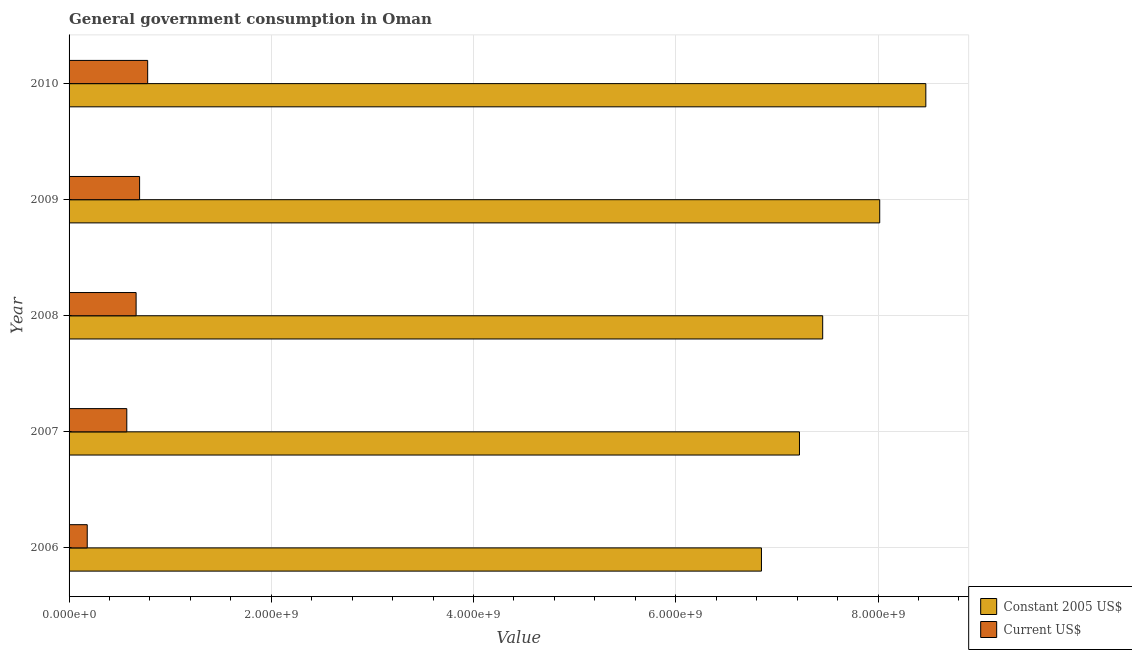How many different coloured bars are there?
Make the answer very short. 2. How many groups of bars are there?
Make the answer very short. 5. Are the number of bars on each tick of the Y-axis equal?
Offer a terse response. Yes. How many bars are there on the 1st tick from the top?
Make the answer very short. 2. How many bars are there on the 3rd tick from the bottom?
Ensure brevity in your answer.  2. What is the label of the 3rd group of bars from the top?
Keep it short and to the point. 2008. In how many cases, is the number of bars for a given year not equal to the number of legend labels?
Make the answer very short. 0. What is the value consumed in current us$ in 2008?
Keep it short and to the point. 6.63e+08. Across all years, what is the maximum value consumed in constant 2005 us$?
Offer a very short reply. 8.47e+09. Across all years, what is the minimum value consumed in constant 2005 us$?
Offer a terse response. 6.85e+09. In which year was the value consumed in constant 2005 us$ maximum?
Offer a very short reply. 2010. What is the total value consumed in current us$ in the graph?
Offer a very short reply. 2.89e+09. What is the difference between the value consumed in current us$ in 2006 and that in 2010?
Your response must be concise. -5.98e+08. What is the difference between the value consumed in constant 2005 us$ in 2008 and the value consumed in current us$ in 2007?
Offer a very short reply. 6.88e+09. What is the average value consumed in constant 2005 us$ per year?
Your answer should be very brief. 7.60e+09. In the year 2007, what is the difference between the value consumed in current us$ and value consumed in constant 2005 us$?
Your response must be concise. -6.65e+09. In how many years, is the value consumed in current us$ greater than 800000000 ?
Provide a succinct answer. 0. What is the ratio of the value consumed in current us$ in 2006 to that in 2007?
Your response must be concise. 0.32. Is the value consumed in current us$ in 2007 less than that in 2008?
Your answer should be compact. Yes. What is the difference between the highest and the second highest value consumed in constant 2005 us$?
Make the answer very short. 4.56e+08. What is the difference between the highest and the lowest value consumed in current us$?
Your response must be concise. 5.98e+08. In how many years, is the value consumed in current us$ greater than the average value consumed in current us$ taken over all years?
Your answer should be very brief. 3. Is the sum of the value consumed in current us$ in 2008 and 2010 greater than the maximum value consumed in constant 2005 us$ across all years?
Give a very brief answer. No. What does the 2nd bar from the top in 2006 represents?
Your answer should be very brief. Constant 2005 US$. What does the 1st bar from the bottom in 2010 represents?
Your answer should be very brief. Constant 2005 US$. How many bars are there?
Offer a very short reply. 10. Are all the bars in the graph horizontal?
Offer a terse response. Yes. Does the graph contain any zero values?
Offer a very short reply. No. Does the graph contain grids?
Make the answer very short. Yes. What is the title of the graph?
Give a very brief answer. General government consumption in Oman. Does "Banks" appear as one of the legend labels in the graph?
Offer a very short reply. No. What is the label or title of the X-axis?
Your response must be concise. Value. What is the label or title of the Y-axis?
Keep it short and to the point. Year. What is the Value in Constant 2005 US$ in 2006?
Provide a succinct answer. 6.85e+09. What is the Value of Current US$ in 2006?
Your answer should be compact. 1.80e+08. What is the Value of Constant 2005 US$ in 2007?
Your answer should be compact. 7.22e+09. What is the Value in Current US$ in 2007?
Offer a terse response. 5.71e+08. What is the Value of Constant 2005 US$ in 2008?
Keep it short and to the point. 7.45e+09. What is the Value in Current US$ in 2008?
Provide a succinct answer. 6.63e+08. What is the Value of Constant 2005 US$ in 2009?
Your answer should be compact. 8.02e+09. What is the Value of Current US$ in 2009?
Your response must be concise. 6.97e+08. What is the Value in Constant 2005 US$ in 2010?
Provide a succinct answer. 8.47e+09. What is the Value in Current US$ in 2010?
Your response must be concise. 7.77e+08. Across all years, what is the maximum Value in Constant 2005 US$?
Your response must be concise. 8.47e+09. Across all years, what is the maximum Value of Current US$?
Your answer should be very brief. 7.77e+08. Across all years, what is the minimum Value in Constant 2005 US$?
Make the answer very short. 6.85e+09. Across all years, what is the minimum Value of Current US$?
Offer a terse response. 1.80e+08. What is the total Value of Constant 2005 US$ in the graph?
Ensure brevity in your answer.  3.80e+1. What is the total Value of Current US$ in the graph?
Provide a short and direct response. 2.89e+09. What is the difference between the Value in Constant 2005 US$ in 2006 and that in 2007?
Your response must be concise. -3.76e+08. What is the difference between the Value of Current US$ in 2006 and that in 2007?
Offer a terse response. -3.91e+08. What is the difference between the Value in Constant 2005 US$ in 2006 and that in 2008?
Your answer should be very brief. -6.06e+08. What is the difference between the Value in Current US$ in 2006 and that in 2008?
Your answer should be compact. -4.83e+08. What is the difference between the Value of Constant 2005 US$ in 2006 and that in 2009?
Offer a very short reply. -1.17e+09. What is the difference between the Value of Current US$ in 2006 and that in 2009?
Make the answer very short. -5.18e+08. What is the difference between the Value of Constant 2005 US$ in 2006 and that in 2010?
Your answer should be compact. -1.63e+09. What is the difference between the Value in Current US$ in 2006 and that in 2010?
Ensure brevity in your answer.  -5.98e+08. What is the difference between the Value in Constant 2005 US$ in 2007 and that in 2008?
Offer a terse response. -2.30e+08. What is the difference between the Value in Current US$ in 2007 and that in 2008?
Your answer should be very brief. -9.21e+07. What is the difference between the Value of Constant 2005 US$ in 2007 and that in 2009?
Offer a very short reply. -7.94e+08. What is the difference between the Value of Current US$ in 2007 and that in 2009?
Give a very brief answer. -1.27e+08. What is the difference between the Value of Constant 2005 US$ in 2007 and that in 2010?
Your response must be concise. -1.25e+09. What is the difference between the Value in Current US$ in 2007 and that in 2010?
Offer a terse response. -2.06e+08. What is the difference between the Value in Constant 2005 US$ in 2008 and that in 2009?
Offer a very short reply. -5.64e+08. What is the difference between the Value in Current US$ in 2008 and that in 2009?
Your response must be concise. -3.45e+07. What is the difference between the Value of Constant 2005 US$ in 2008 and that in 2010?
Your answer should be very brief. -1.02e+09. What is the difference between the Value in Current US$ in 2008 and that in 2010?
Ensure brevity in your answer.  -1.14e+08. What is the difference between the Value of Constant 2005 US$ in 2009 and that in 2010?
Your answer should be very brief. -4.56e+08. What is the difference between the Value in Current US$ in 2009 and that in 2010?
Provide a succinct answer. -7.99e+07. What is the difference between the Value of Constant 2005 US$ in 2006 and the Value of Current US$ in 2007?
Ensure brevity in your answer.  6.28e+09. What is the difference between the Value of Constant 2005 US$ in 2006 and the Value of Current US$ in 2008?
Give a very brief answer. 6.18e+09. What is the difference between the Value of Constant 2005 US$ in 2006 and the Value of Current US$ in 2009?
Offer a very short reply. 6.15e+09. What is the difference between the Value in Constant 2005 US$ in 2006 and the Value in Current US$ in 2010?
Your response must be concise. 6.07e+09. What is the difference between the Value in Constant 2005 US$ in 2007 and the Value in Current US$ in 2008?
Offer a very short reply. 6.56e+09. What is the difference between the Value of Constant 2005 US$ in 2007 and the Value of Current US$ in 2009?
Your answer should be very brief. 6.53e+09. What is the difference between the Value in Constant 2005 US$ in 2007 and the Value in Current US$ in 2010?
Keep it short and to the point. 6.45e+09. What is the difference between the Value of Constant 2005 US$ in 2008 and the Value of Current US$ in 2009?
Your answer should be compact. 6.76e+09. What is the difference between the Value of Constant 2005 US$ in 2008 and the Value of Current US$ in 2010?
Give a very brief answer. 6.68e+09. What is the difference between the Value of Constant 2005 US$ in 2009 and the Value of Current US$ in 2010?
Your answer should be very brief. 7.24e+09. What is the average Value in Constant 2005 US$ per year?
Make the answer very short. 7.60e+09. What is the average Value in Current US$ per year?
Your answer should be compact. 5.78e+08. In the year 2006, what is the difference between the Value in Constant 2005 US$ and Value in Current US$?
Your response must be concise. 6.67e+09. In the year 2007, what is the difference between the Value in Constant 2005 US$ and Value in Current US$?
Give a very brief answer. 6.65e+09. In the year 2008, what is the difference between the Value in Constant 2005 US$ and Value in Current US$?
Provide a succinct answer. 6.79e+09. In the year 2009, what is the difference between the Value of Constant 2005 US$ and Value of Current US$?
Ensure brevity in your answer.  7.32e+09. In the year 2010, what is the difference between the Value of Constant 2005 US$ and Value of Current US$?
Your answer should be compact. 7.70e+09. What is the ratio of the Value in Constant 2005 US$ in 2006 to that in 2007?
Ensure brevity in your answer.  0.95. What is the ratio of the Value in Current US$ in 2006 to that in 2007?
Make the answer very short. 0.31. What is the ratio of the Value of Constant 2005 US$ in 2006 to that in 2008?
Offer a terse response. 0.92. What is the ratio of the Value in Current US$ in 2006 to that in 2008?
Make the answer very short. 0.27. What is the ratio of the Value of Constant 2005 US$ in 2006 to that in 2009?
Your answer should be very brief. 0.85. What is the ratio of the Value in Current US$ in 2006 to that in 2009?
Offer a very short reply. 0.26. What is the ratio of the Value in Constant 2005 US$ in 2006 to that in 2010?
Keep it short and to the point. 0.81. What is the ratio of the Value of Current US$ in 2006 to that in 2010?
Ensure brevity in your answer.  0.23. What is the ratio of the Value of Constant 2005 US$ in 2007 to that in 2008?
Your answer should be compact. 0.97. What is the ratio of the Value in Current US$ in 2007 to that in 2008?
Your answer should be compact. 0.86. What is the ratio of the Value in Constant 2005 US$ in 2007 to that in 2009?
Offer a very short reply. 0.9. What is the ratio of the Value in Current US$ in 2007 to that in 2009?
Ensure brevity in your answer.  0.82. What is the ratio of the Value in Constant 2005 US$ in 2007 to that in 2010?
Give a very brief answer. 0.85. What is the ratio of the Value of Current US$ in 2007 to that in 2010?
Your response must be concise. 0.73. What is the ratio of the Value of Constant 2005 US$ in 2008 to that in 2009?
Keep it short and to the point. 0.93. What is the ratio of the Value of Current US$ in 2008 to that in 2009?
Provide a short and direct response. 0.95. What is the ratio of the Value of Constant 2005 US$ in 2008 to that in 2010?
Keep it short and to the point. 0.88. What is the ratio of the Value in Current US$ in 2008 to that in 2010?
Your answer should be very brief. 0.85. What is the ratio of the Value in Constant 2005 US$ in 2009 to that in 2010?
Ensure brevity in your answer.  0.95. What is the ratio of the Value of Current US$ in 2009 to that in 2010?
Give a very brief answer. 0.9. What is the difference between the highest and the second highest Value in Constant 2005 US$?
Provide a succinct answer. 4.56e+08. What is the difference between the highest and the second highest Value in Current US$?
Provide a succinct answer. 7.99e+07. What is the difference between the highest and the lowest Value in Constant 2005 US$?
Ensure brevity in your answer.  1.63e+09. What is the difference between the highest and the lowest Value of Current US$?
Your answer should be very brief. 5.98e+08. 